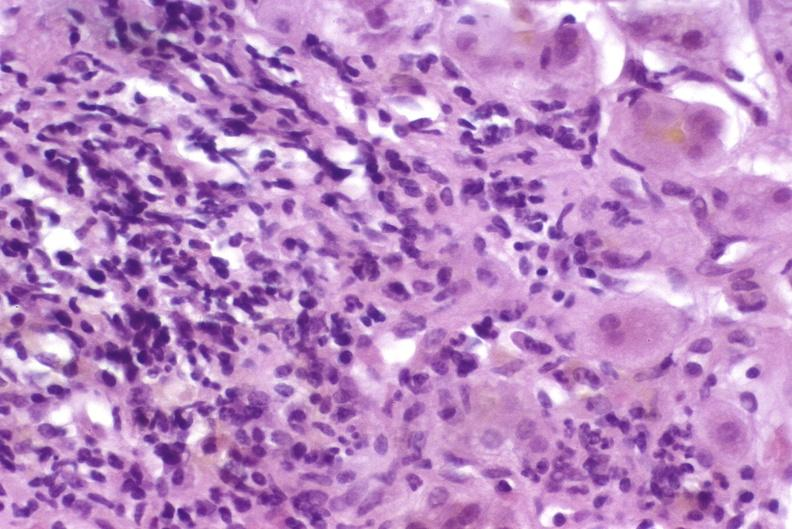s liver present?
Answer the question using a single word or phrase. Yes 